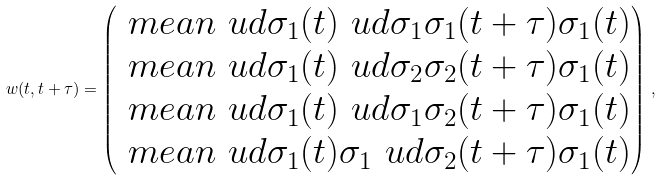<formula> <loc_0><loc_0><loc_500><loc_500>w ( t , t + \tau ) = \begin{pmatrix} \ m e a n { \ u d { \sigma _ { 1 } } ( t ) \ u d { \sigma _ { 1 } } \sigma _ { 1 } ( t + \tau ) \sigma _ { 1 } ( t ) } \\ \ m e a n { \ u d { \sigma _ { 1 } } ( t ) \ u d { \sigma _ { 2 } } \sigma _ { 2 } ( t + \tau ) \sigma _ { 1 } ( t ) } \\ \ m e a n { \ u d { \sigma _ { 1 } } ( t ) \ u d { \sigma _ { 1 } } \sigma _ { 2 } ( t + \tau ) \sigma _ { 1 } ( t ) } \\ \ m e a n { \ u d { \sigma _ { 1 } } ( t ) \sigma _ { 1 } \ u d { \sigma _ { 2 } } ( t + \tau ) \sigma _ { 1 } ( t ) } \end{pmatrix} \, ,</formula> 